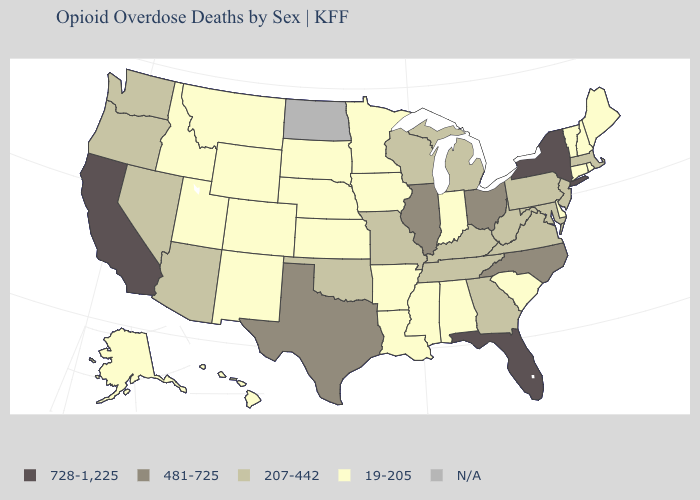Which states have the highest value in the USA?
Be succinct. California, Florida, New York. Which states have the highest value in the USA?
Be succinct. California, Florida, New York. Does New York have the highest value in the Northeast?
Be succinct. Yes. What is the value of West Virginia?
Concise answer only. 207-442. Does New Jersey have the highest value in the USA?
Concise answer only. No. What is the value of Missouri?
Short answer required. 207-442. What is the lowest value in the West?
Short answer required. 19-205. Name the states that have a value in the range 19-205?
Concise answer only. Alabama, Alaska, Arkansas, Colorado, Connecticut, Delaware, Hawaii, Idaho, Indiana, Iowa, Kansas, Louisiana, Maine, Minnesota, Mississippi, Montana, Nebraska, New Hampshire, New Mexico, Rhode Island, South Carolina, South Dakota, Utah, Vermont, Wyoming. Name the states that have a value in the range 19-205?
Write a very short answer. Alabama, Alaska, Arkansas, Colorado, Connecticut, Delaware, Hawaii, Idaho, Indiana, Iowa, Kansas, Louisiana, Maine, Minnesota, Mississippi, Montana, Nebraska, New Hampshire, New Mexico, Rhode Island, South Carolina, South Dakota, Utah, Vermont, Wyoming. Is the legend a continuous bar?
Concise answer only. No. Among the states that border Iowa , which have the highest value?
Keep it brief. Illinois. What is the value of Virginia?
Short answer required. 207-442. Among the states that border Ohio , which have the lowest value?
Concise answer only. Indiana. Name the states that have a value in the range 207-442?
Be succinct. Arizona, Georgia, Kentucky, Maryland, Massachusetts, Michigan, Missouri, Nevada, New Jersey, Oklahoma, Oregon, Pennsylvania, Tennessee, Virginia, Washington, West Virginia, Wisconsin. 